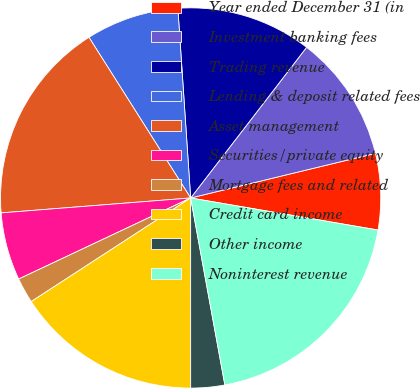Convert chart to OTSL. <chart><loc_0><loc_0><loc_500><loc_500><pie_chart><fcel>Year ended December 31 (in<fcel>Investment banking fees<fcel>Trading revenue<fcel>Lending & deposit related fees<fcel>Asset management<fcel>Securities/private equity<fcel>Mortgage fees and related<fcel>Credit card income<fcel>Other income<fcel>Noninterest revenue<nl><fcel>6.47%<fcel>10.79%<fcel>11.51%<fcel>7.91%<fcel>17.27%<fcel>5.76%<fcel>2.16%<fcel>15.83%<fcel>2.88%<fcel>19.42%<nl></chart> 